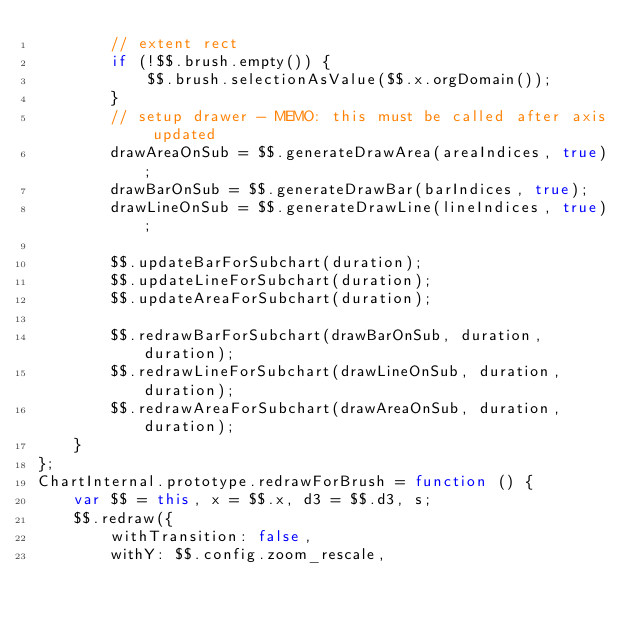<code> <loc_0><loc_0><loc_500><loc_500><_JavaScript_>        // extent rect
        if (!$$.brush.empty()) {
            $$.brush.selectionAsValue($$.x.orgDomain());
        }
        // setup drawer - MEMO: this must be called after axis updated
        drawAreaOnSub = $$.generateDrawArea(areaIndices, true);
        drawBarOnSub = $$.generateDrawBar(barIndices, true);
        drawLineOnSub = $$.generateDrawLine(lineIndices, true);

        $$.updateBarForSubchart(duration);
        $$.updateLineForSubchart(duration);
        $$.updateAreaForSubchart(duration);

        $$.redrawBarForSubchart(drawBarOnSub, duration, duration);
        $$.redrawLineForSubchart(drawLineOnSub, duration, duration);
        $$.redrawAreaForSubchart(drawAreaOnSub, duration, duration);
    }
};
ChartInternal.prototype.redrawForBrush = function () {
    var $$ = this, x = $$.x, d3 = $$.d3, s;
    $$.redraw({
        withTransition: false,
        withY: $$.config.zoom_rescale,</code> 